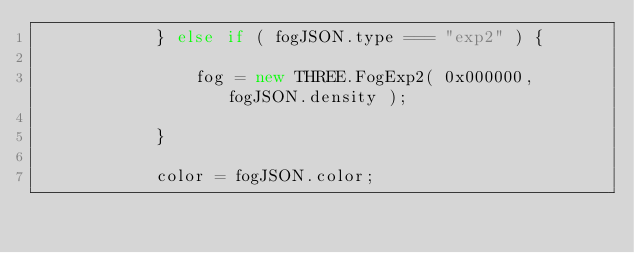Convert code to text. <code><loc_0><loc_0><loc_500><loc_500><_JavaScript_>			} else if ( fogJSON.type === "exp2" ) {

				fog = new THREE.FogExp2( 0x000000, fogJSON.density );

			}

			color = fogJSON.color;</code> 